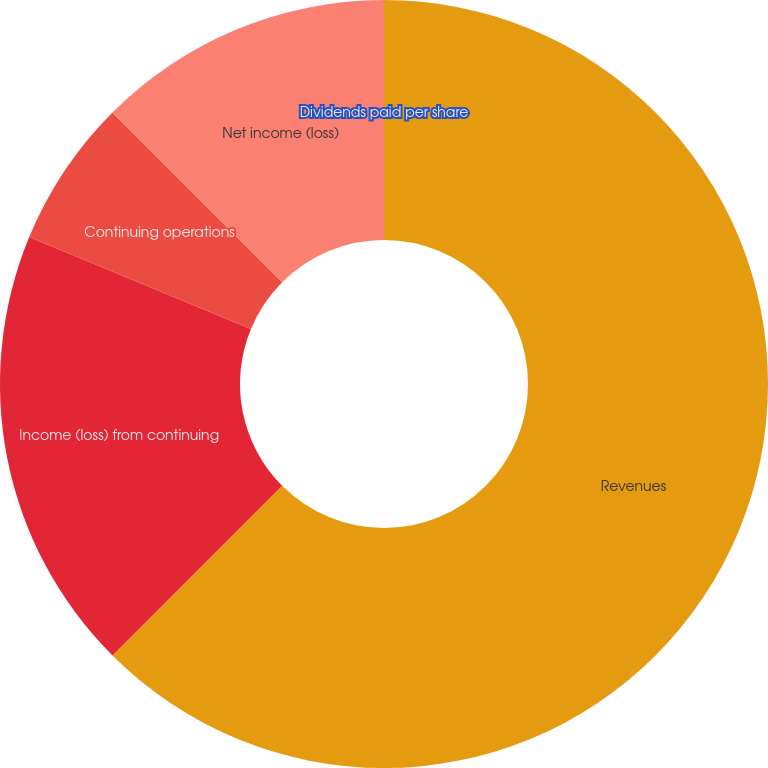Convert chart. <chart><loc_0><loc_0><loc_500><loc_500><pie_chart><fcel>Revenues<fcel>Income (loss) from continuing<fcel>Continuing operations<fcel>Net income (loss)<fcel>Dividends paid per share<nl><fcel>62.49%<fcel>18.75%<fcel>6.25%<fcel>12.5%<fcel>0.0%<nl></chart> 